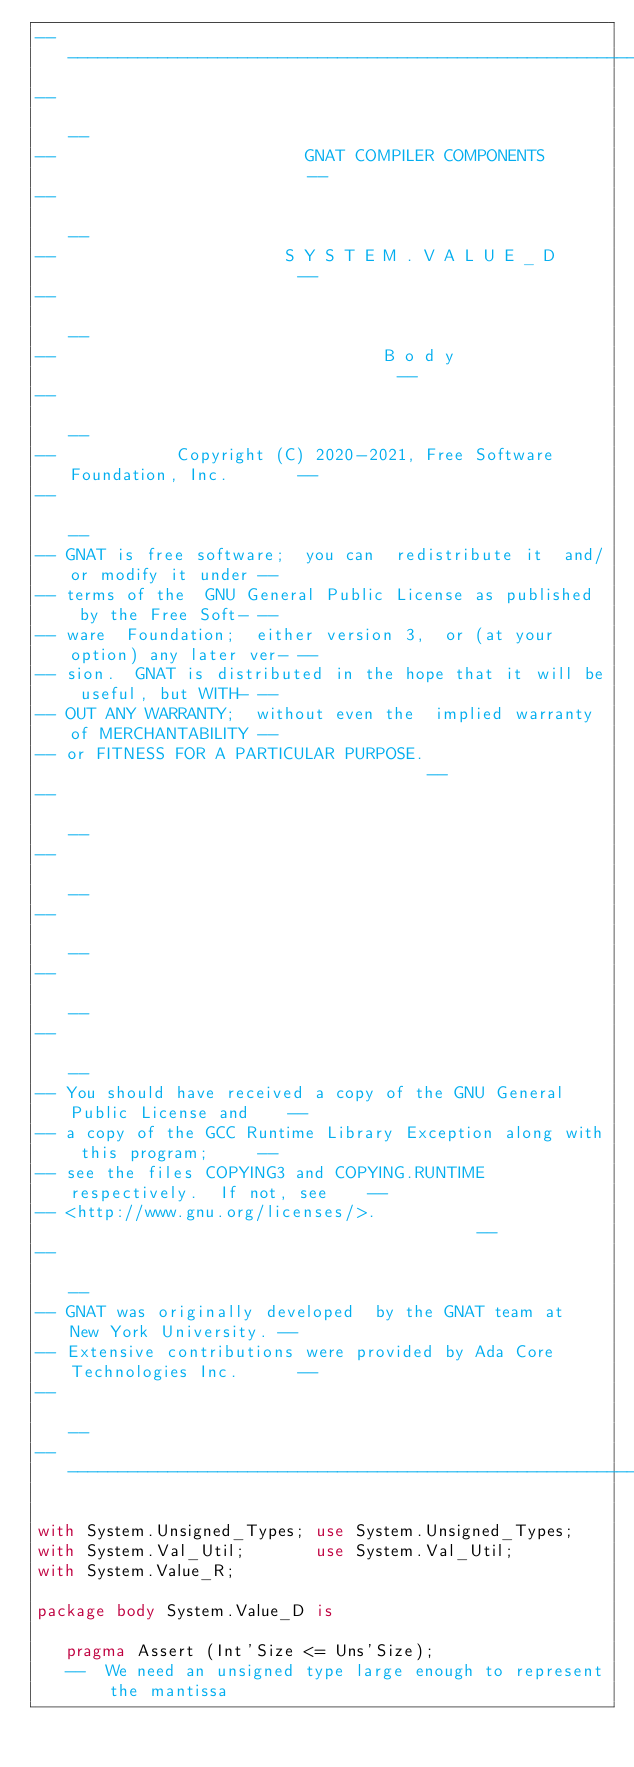<code> <loc_0><loc_0><loc_500><loc_500><_Ada_>------------------------------------------------------------------------------
--                                                                          --
--                         GNAT COMPILER COMPONENTS                         --
--                                                                          --
--                       S Y S T E M . V A L U E _ D                        --
--                                                                          --
--                                 B o d y                                  --
--                                                                          --
--            Copyright (C) 2020-2021, Free Software Foundation, Inc.       --
--                                                                          --
-- GNAT is free software;  you can  redistribute it  and/or modify it under --
-- terms of the  GNU General Public License as published  by the Free Soft- --
-- ware  Foundation;  either version 3,  or (at your option) any later ver- --
-- sion.  GNAT is distributed in the hope that it will be useful, but WITH- --
-- OUT ANY WARRANTY;  without even the  implied warranty of MERCHANTABILITY --
-- or FITNESS FOR A PARTICULAR PURPOSE.                                     --
--                                                                          --
--                                                                          --
--                                                                          --
--                                                                          --
--                                                                          --
-- You should have received a copy of the GNU General Public License and    --
-- a copy of the GCC Runtime Library Exception along with this program;     --
-- see the files COPYING3 and COPYING.RUNTIME respectively.  If not, see    --
-- <http://www.gnu.org/licenses/>.                                          --
--                                                                          --
-- GNAT was originally developed  by the GNAT team at  New York University. --
-- Extensive contributions were provided by Ada Core Technologies Inc.      --
--                                                                          --
------------------------------------------------------------------------------

with System.Unsigned_Types; use System.Unsigned_Types;
with System.Val_Util;       use System.Val_Util;
with System.Value_R;

package body System.Value_D is

   pragma Assert (Int'Size <= Uns'Size);
   --  We need an unsigned type large enough to represent the mantissa
</code> 